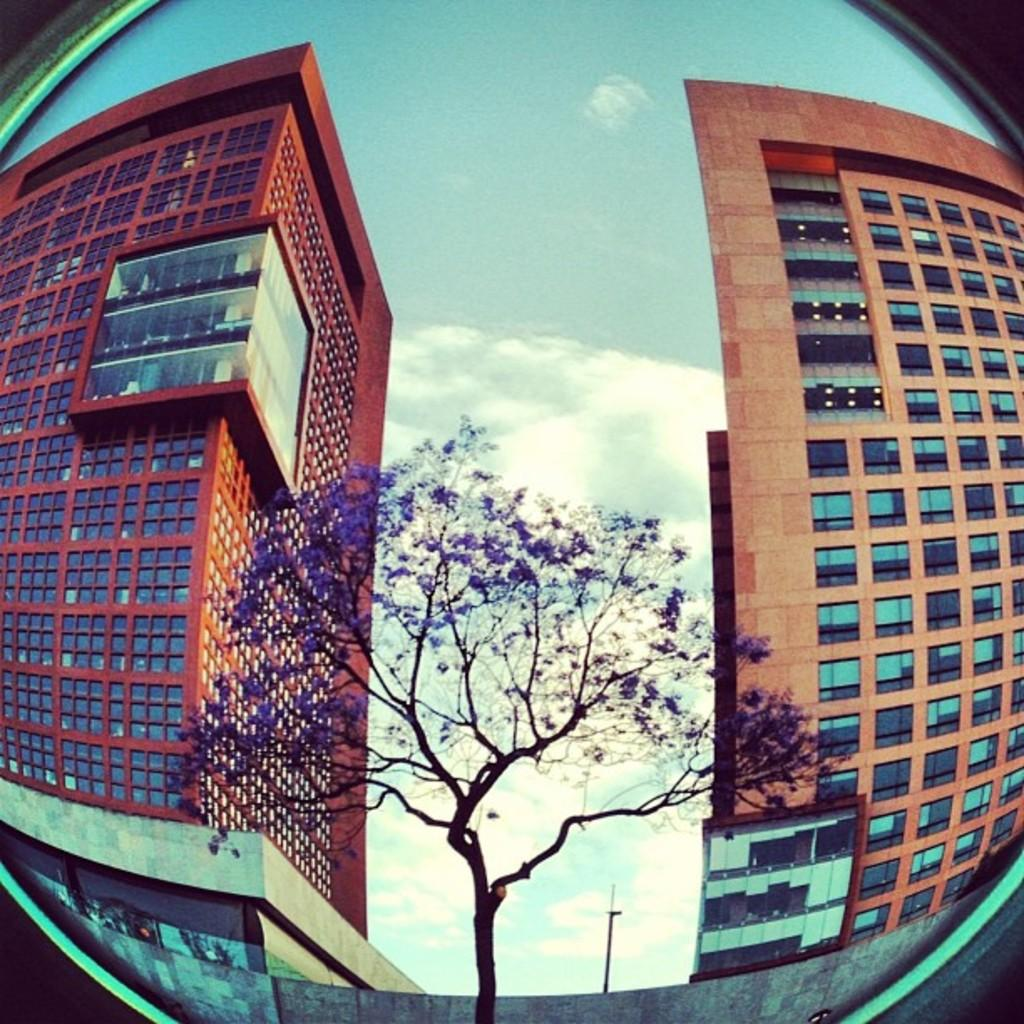What type of images are present in the picture? The image contains edited pictures of buildings. Are there any natural elements in the image? Yes, there is a tree in the image. What other objects can be seen in the image? There is a pole in the image. What is visible in the background of the image? The sky is visible in the image. How would you describe the weather based on the sky in the image? The sky appears cloudy in the image. What type of shoes is the tree wearing in the image? There are no shoes present in the image, as the tree is a natural element and not a person or object that can wear shoes. 